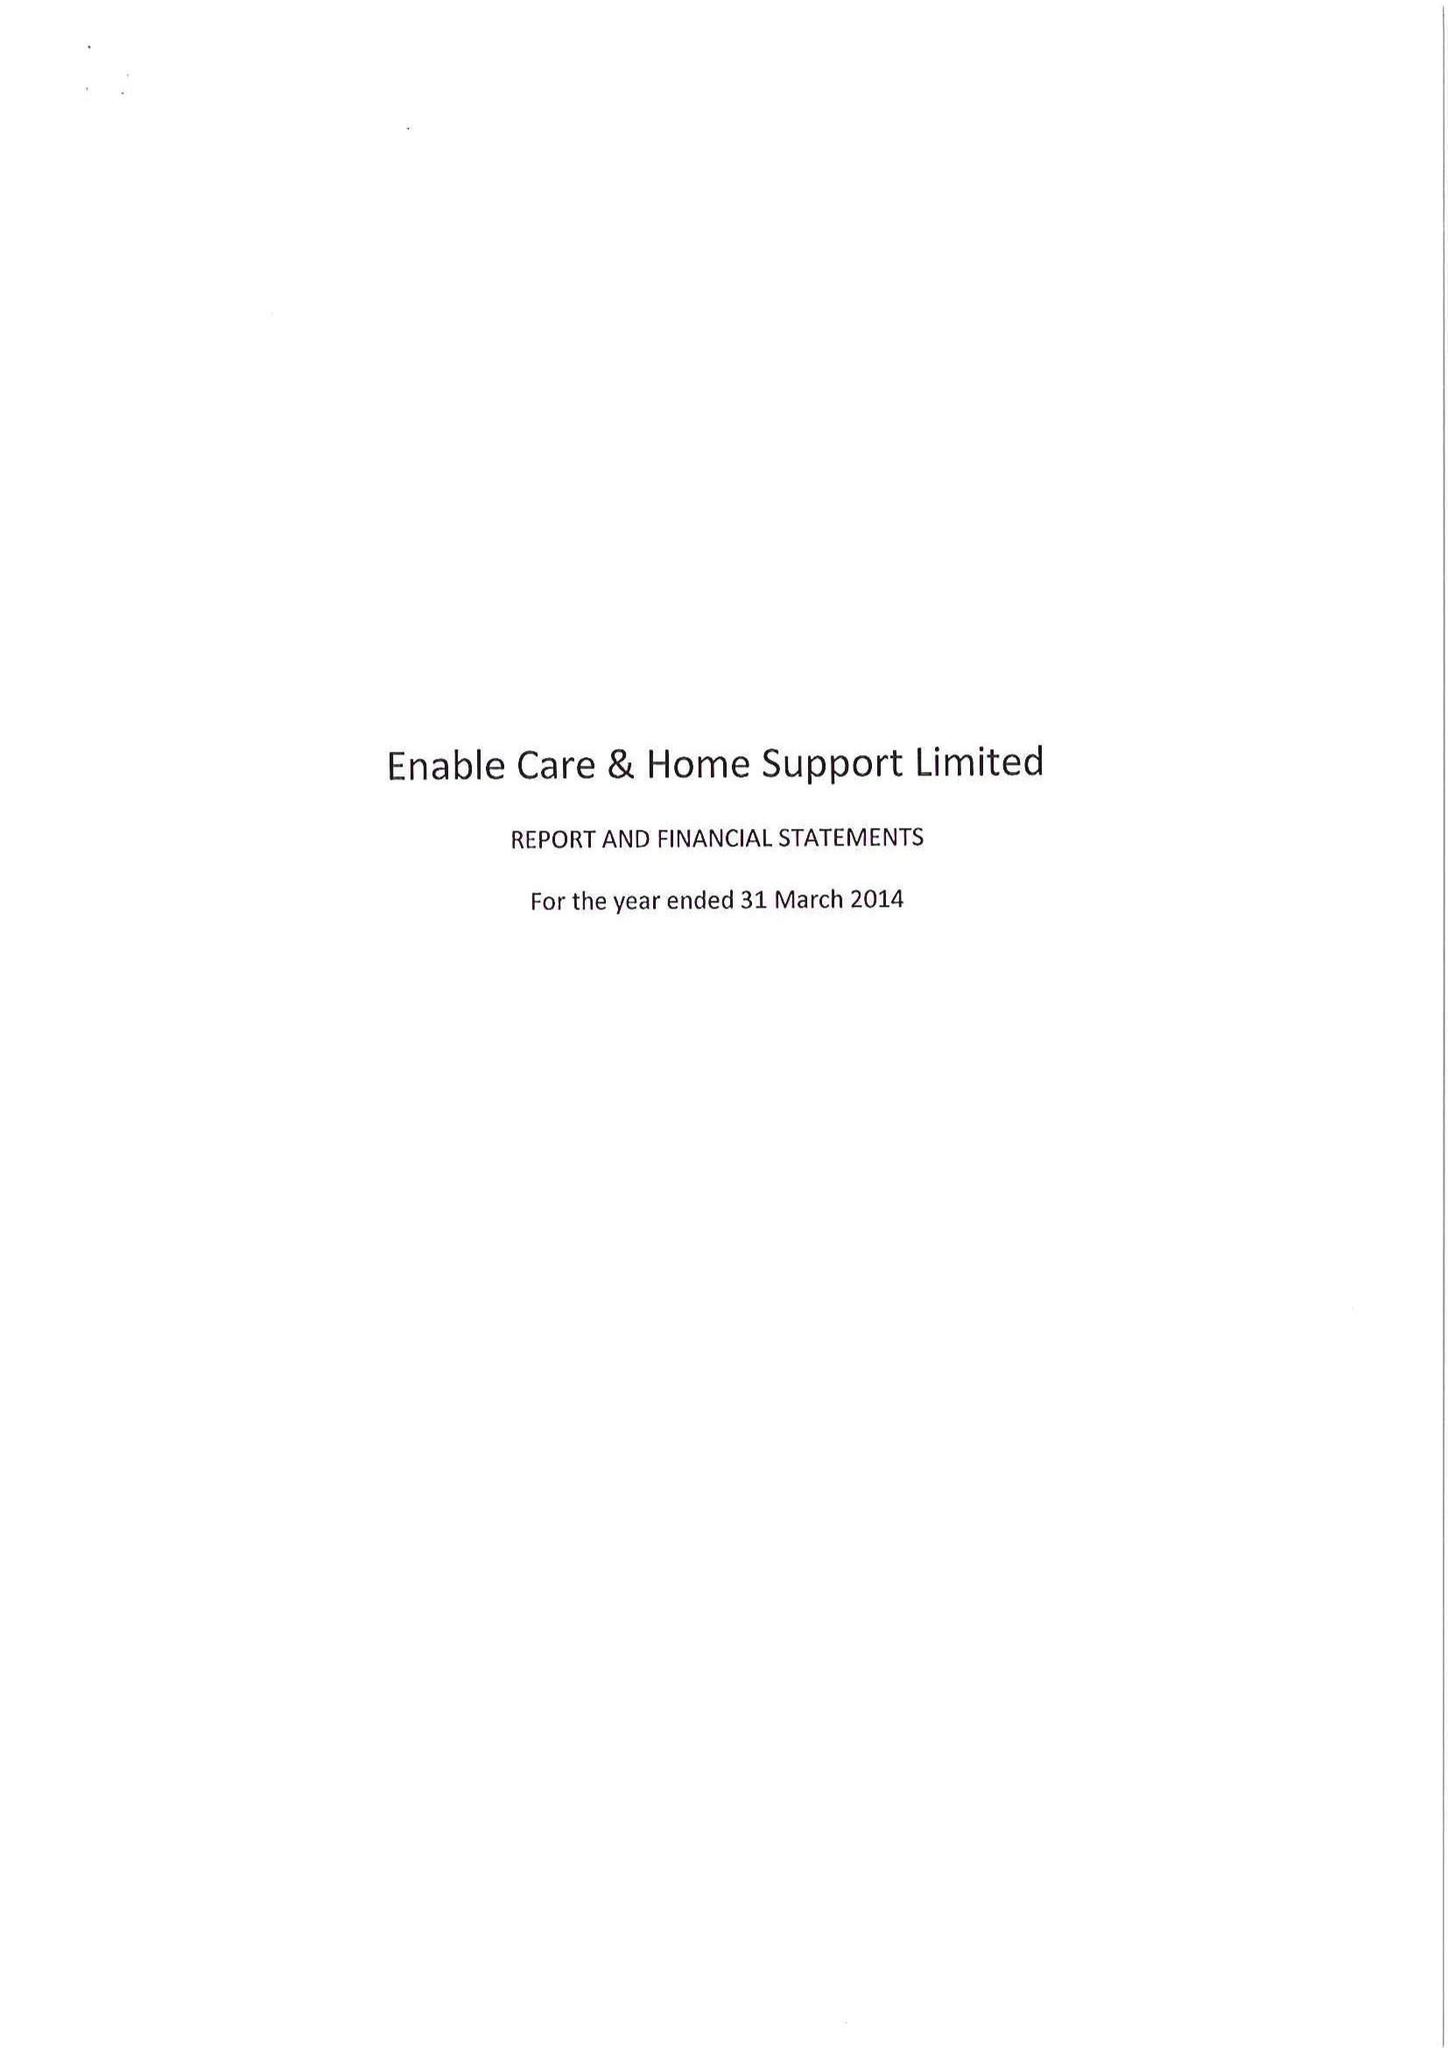What is the value for the spending_annually_in_british_pounds?
Answer the question using a single word or phrase. 14356000.00 